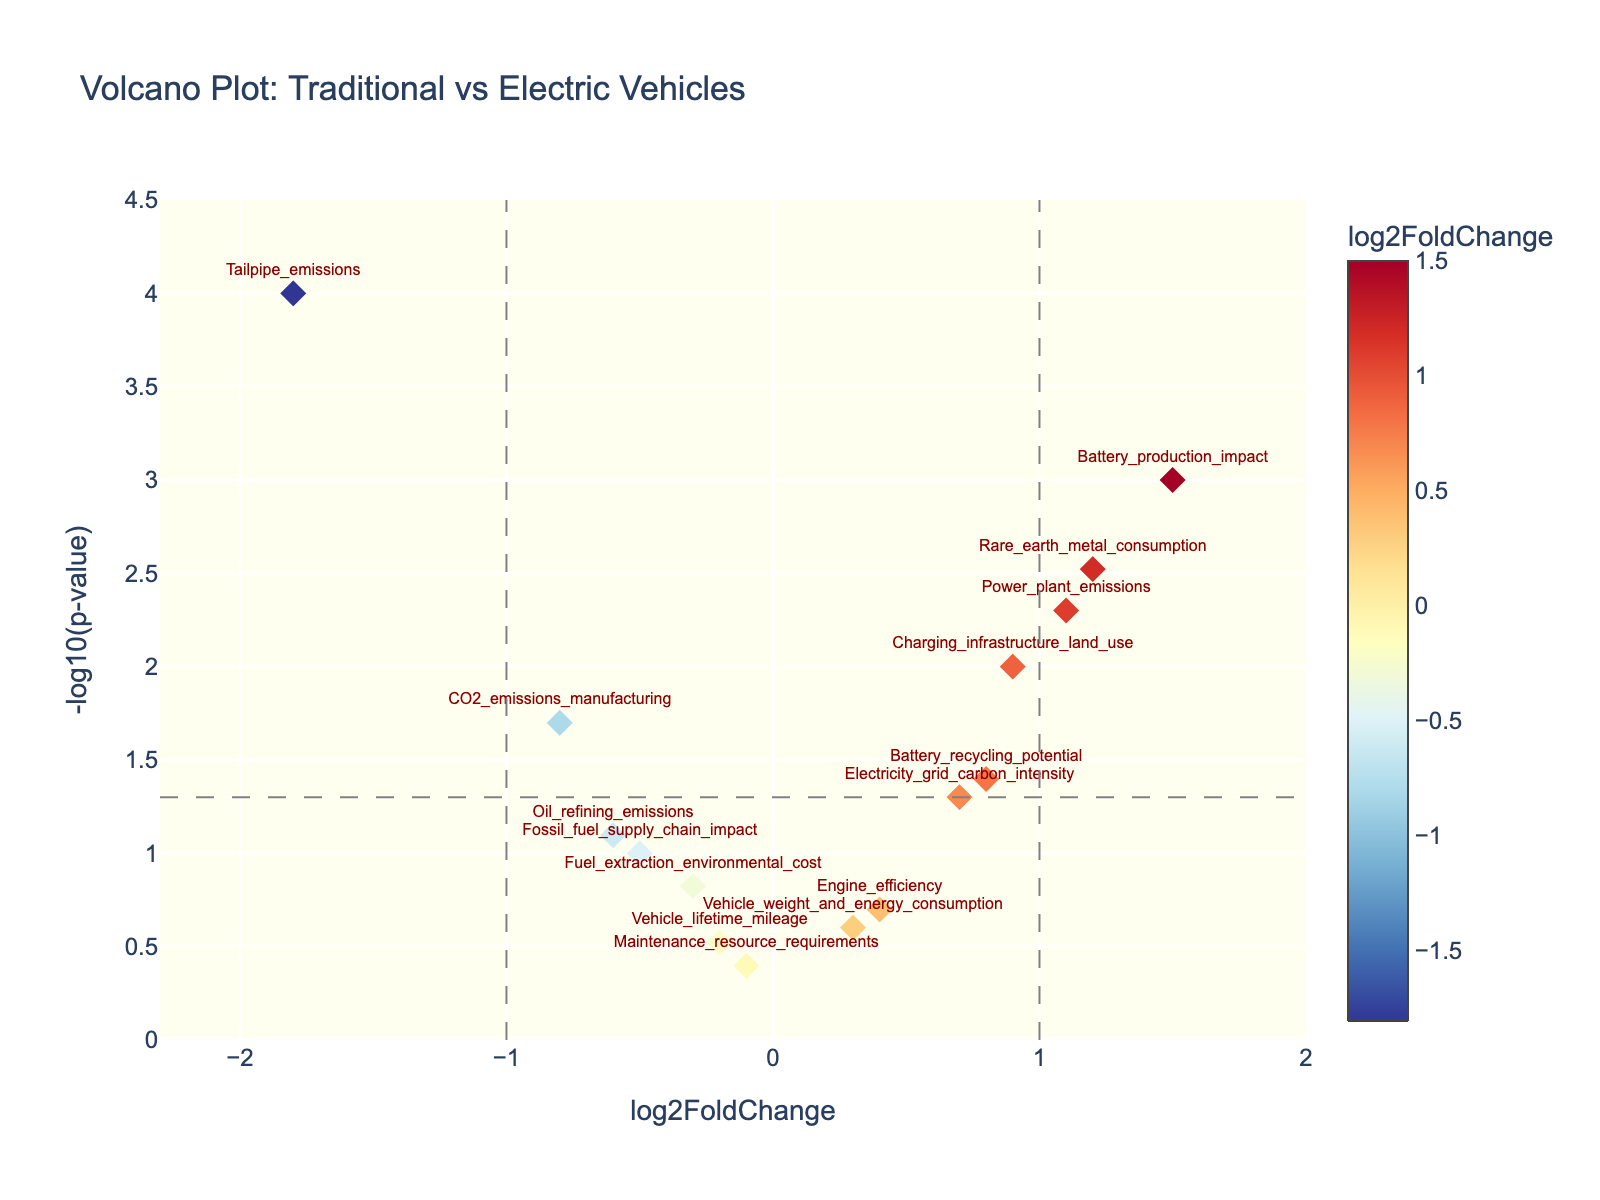What does the x-axis represent in the plot? The x-axis represents the log2FoldChange values, which indicate the changes in log2 scale between traditional and electric vehicles' environmental impact and resource consumption metrics.
Answer: log2FoldChange values What is represented on the y-axis? The y-axis represents the -log10 of the p-values associated with the changes in the variables, indicating the statistical significance of those changes.
Answer: -log10(p-value) Which variable shows the highest positive log2FoldChange value? The highest positive log2FoldChange value is represented by Battery_production_impact based on its position furthest to the right on the x-axis.
Answer: Battery_production_impact How many data points are above the significance threshold? The significance threshold is set at -log10(p-value) > 1.30. The data points located higher than this threshold are Battery_production_impact, Rare_earth_metal_consumption, Charging_infrastructure_land_use, Tailpipe_emissions, Battery_recycling_potential, and Power_plant_emissions.
Answer: 6 Which variable is both statistically significant and has the most negative log2FoldChange value? The variable Tailpipe_emissions is both statistically significant and has the most negative log2FoldChange value, indicating it falls below the significance threshold line and is furthest to the left on the log2FoldChange axis.
Answer: Tailpipe_emissions Compare CO2_emissions_manufacturing and Battery_production_impact. Which has a higher value in terms of the statistical significance of their difference? Battery_production_impact has both a higher log2FoldChange and a higher -log10(p-value) compared to CO2_emissions_manufacturing, signifying a more significant difference.
Answer: Battery_production_impact What does the plot imply about the environmental impact of Battery production for electric vehicles? The plot indicates that Battery_production_impact has a high positive log2FoldChange and a very low p-value, implying significant environmental impact compared to traditional vehicles.
Answer: Significant impact Which variable related to traditional fuels has the least impact in terms of both log2FoldChange and statistical significance? Maintenance_resource_requirements appears close to the origin on both axes, indicating the least impact in terms of log2FoldChange and statistical significance.
Answer: Maintenance_resource_requirements 